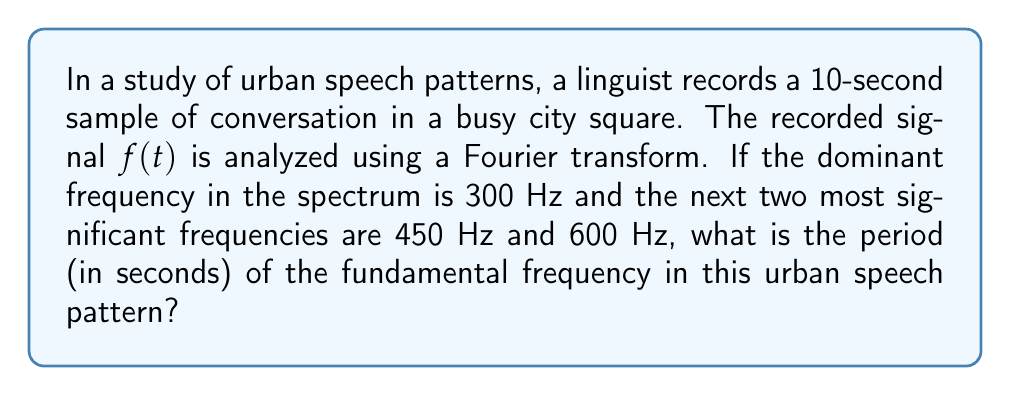Can you solve this math problem? To solve this problem, we'll follow these steps:

1) First, recall that frequency $(f)$ and period $(T)$ are inversely related:

   $$T = \frac{1}{f}$$

2) The fundamental frequency is the lowest frequency in a harmonic series. In this case, it's the greatest common divisor (GCD) of the given frequencies:

   $$f_{fundamental} = GCD(300, 450, 600)$$

3) To find the GCD:
   - 300 = 2^2 * 3 * 5^2
   - 450 = 2 * 3^2 * 5^2
   - 600 = 2^3 * 3 * 5^2

   The GCD is the product of the common factors with the lowest exponents:
   $$GCD = 2 * 3 * 5^2 = 150 Hz$$

4) Now that we have the fundamental frequency, we can calculate its period:

   $$T = \frac{1}{f_{fundamental}} = \frac{1}{150} = \frac{1}{150} \text{ seconds}$$

5) To simplify this fraction:
   $$\frac{1}{150} = \frac{1}{2 * 3 * 5^2} = \frac{1}{2 * 3 * 25} = \frac{1}{150} = \frac{2}{300} = \frac{1}{150} \text{ seconds}$$

Thus, the period of the fundamental frequency is $\frac{1}{150}$ seconds.
Answer: $\frac{1}{150}$ seconds 